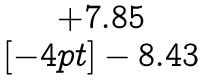<formula> <loc_0><loc_0><loc_500><loc_500>\begin{matrix} + 7 . 8 5 \\ [ - 4 p t ] - 8 . 4 3 \end{matrix}</formula> 